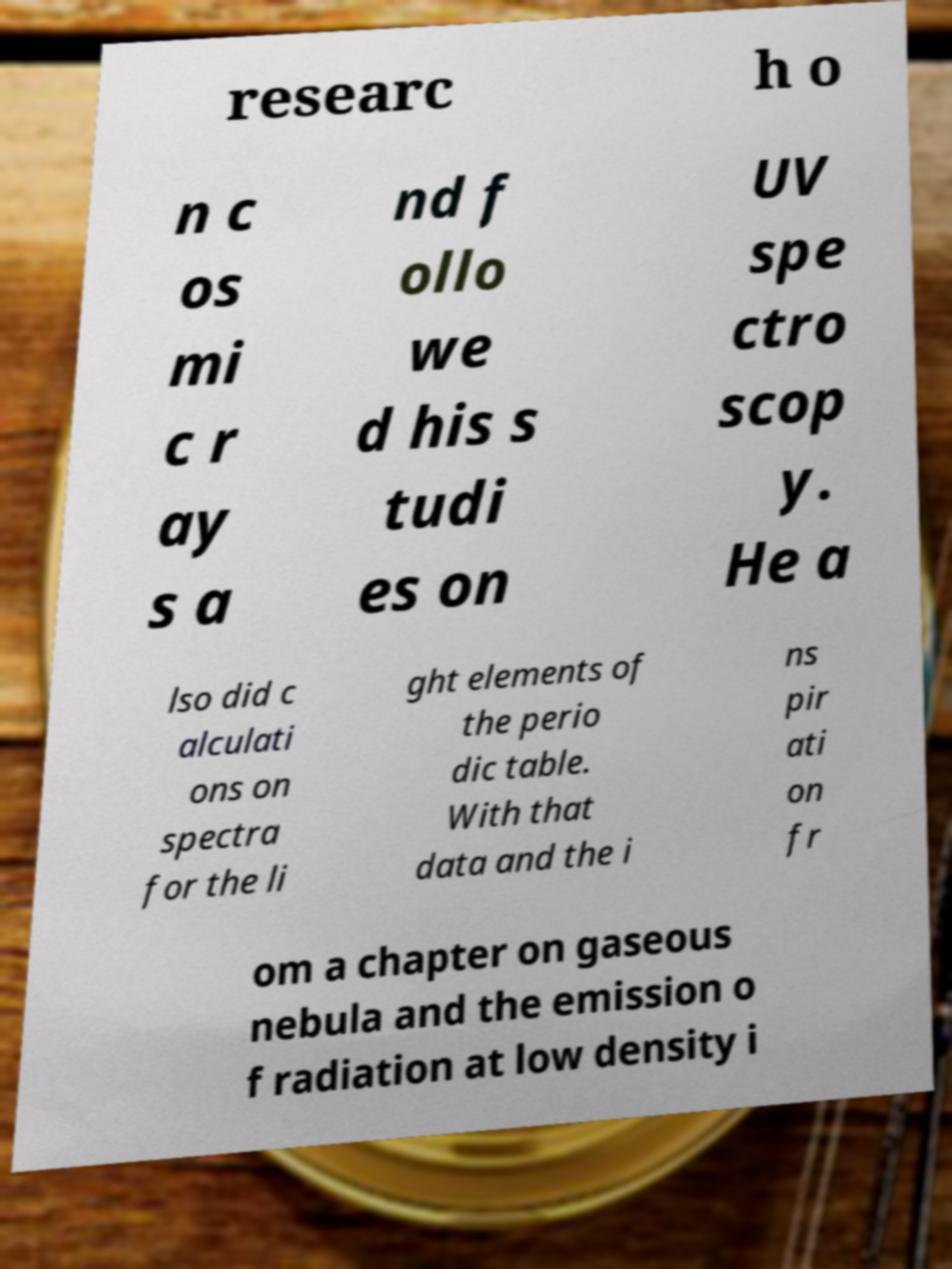Can you accurately transcribe the text from the provided image for me? researc h o n c os mi c r ay s a nd f ollo we d his s tudi es on UV spe ctro scop y. He a lso did c alculati ons on spectra for the li ght elements of the perio dic table. With that data and the i ns pir ati on fr om a chapter on gaseous nebula and the emission o f radiation at low density i 